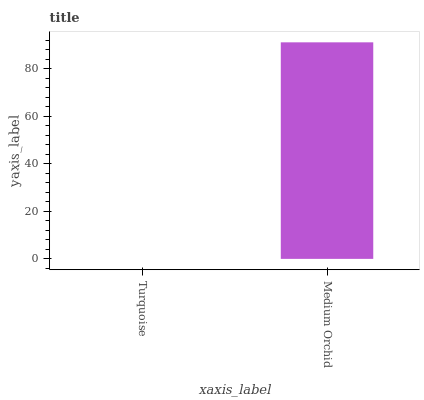Is Turquoise the minimum?
Answer yes or no. Yes. Is Medium Orchid the maximum?
Answer yes or no. Yes. Is Medium Orchid the minimum?
Answer yes or no. No. Is Medium Orchid greater than Turquoise?
Answer yes or no. Yes. Is Turquoise less than Medium Orchid?
Answer yes or no. Yes. Is Turquoise greater than Medium Orchid?
Answer yes or no. No. Is Medium Orchid less than Turquoise?
Answer yes or no. No. Is Medium Orchid the high median?
Answer yes or no. Yes. Is Turquoise the low median?
Answer yes or no. Yes. Is Turquoise the high median?
Answer yes or no. No. Is Medium Orchid the low median?
Answer yes or no. No. 